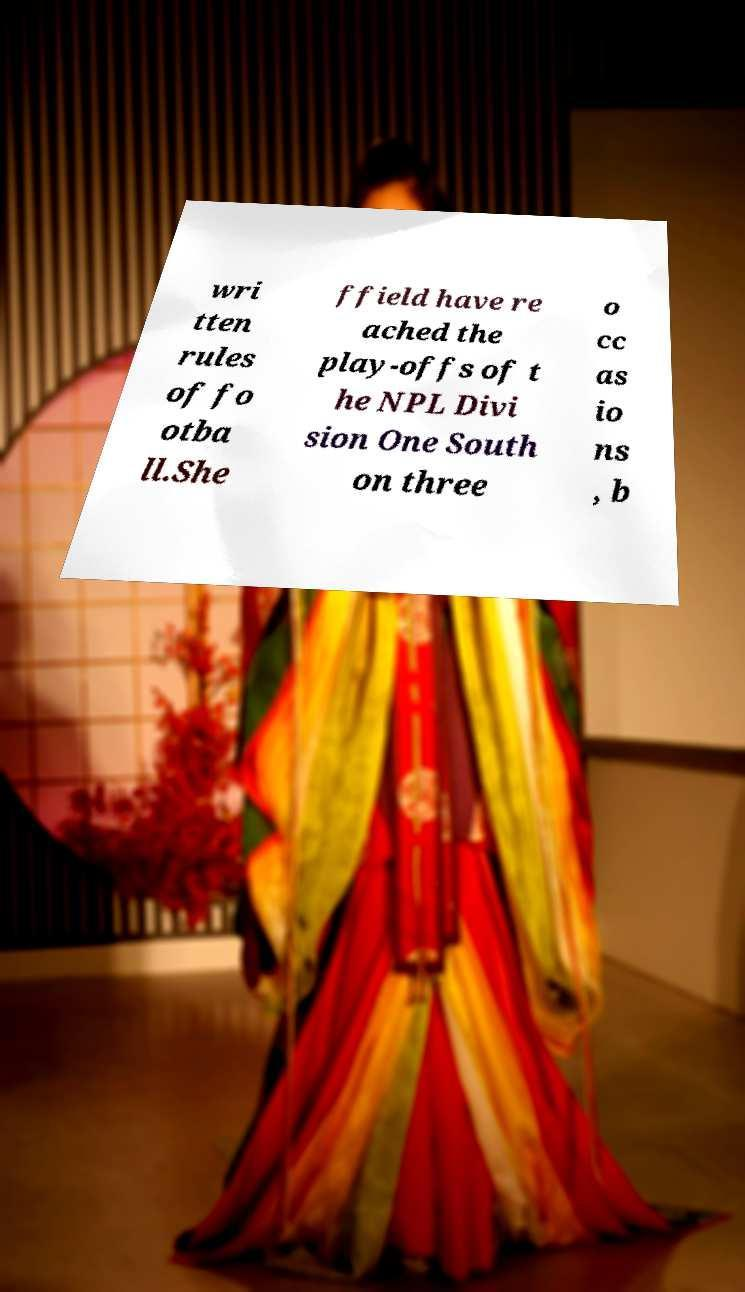What messages or text are displayed in this image? I need them in a readable, typed format. wri tten rules of fo otba ll.She ffield have re ached the play-offs of t he NPL Divi sion One South on three o cc as io ns , b 